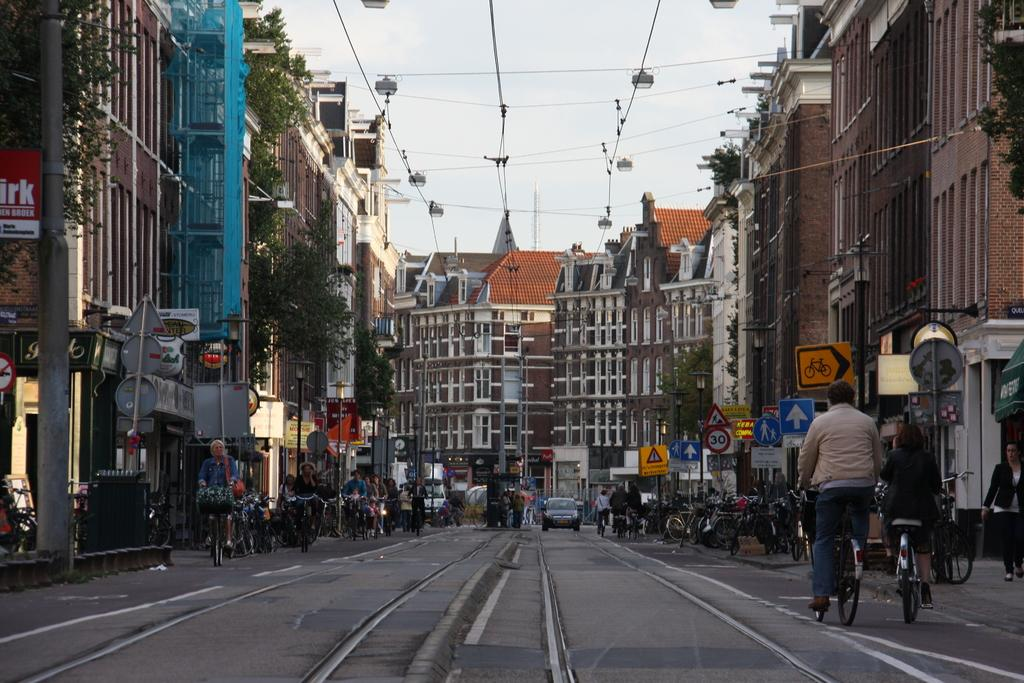What type of structures can be seen in the image? There are buildings in the image. What object is present in the middle of the road? There is a pole in the middle of the road. What are the people in the image doing? People are riding bicycles on the road. Can you see any vehicles in the image? Yes, there is a car visible in the distance. What else can be seen on the road or near the buildings? There are sign boards in the image. How many pizzas are being delivered by the bicycle riders in the image? There is no indication of pizzas or delivery in the image; people are simply riding bicycles. 